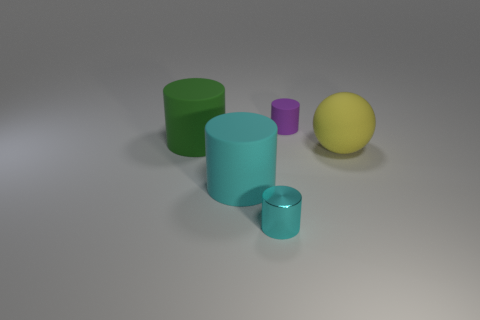Add 3 big red metal cubes. How many objects exist? 8 Subtract all spheres. How many objects are left? 4 Subtract 0 purple blocks. How many objects are left? 5 Subtract all large purple cubes. Subtract all green cylinders. How many objects are left? 4 Add 2 yellow things. How many yellow things are left? 3 Add 5 cyan matte cylinders. How many cyan matte cylinders exist? 6 